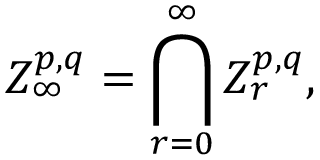Convert formula to latex. <formula><loc_0><loc_0><loc_500><loc_500>Z _ { \infty } ^ { p , q } = \bigcap _ { r = 0 } ^ { \infty } Z _ { r } ^ { p , q } ,</formula> 